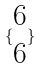<formula> <loc_0><loc_0><loc_500><loc_500>\{ \begin{matrix} 6 \\ 6 \end{matrix} \}</formula> 